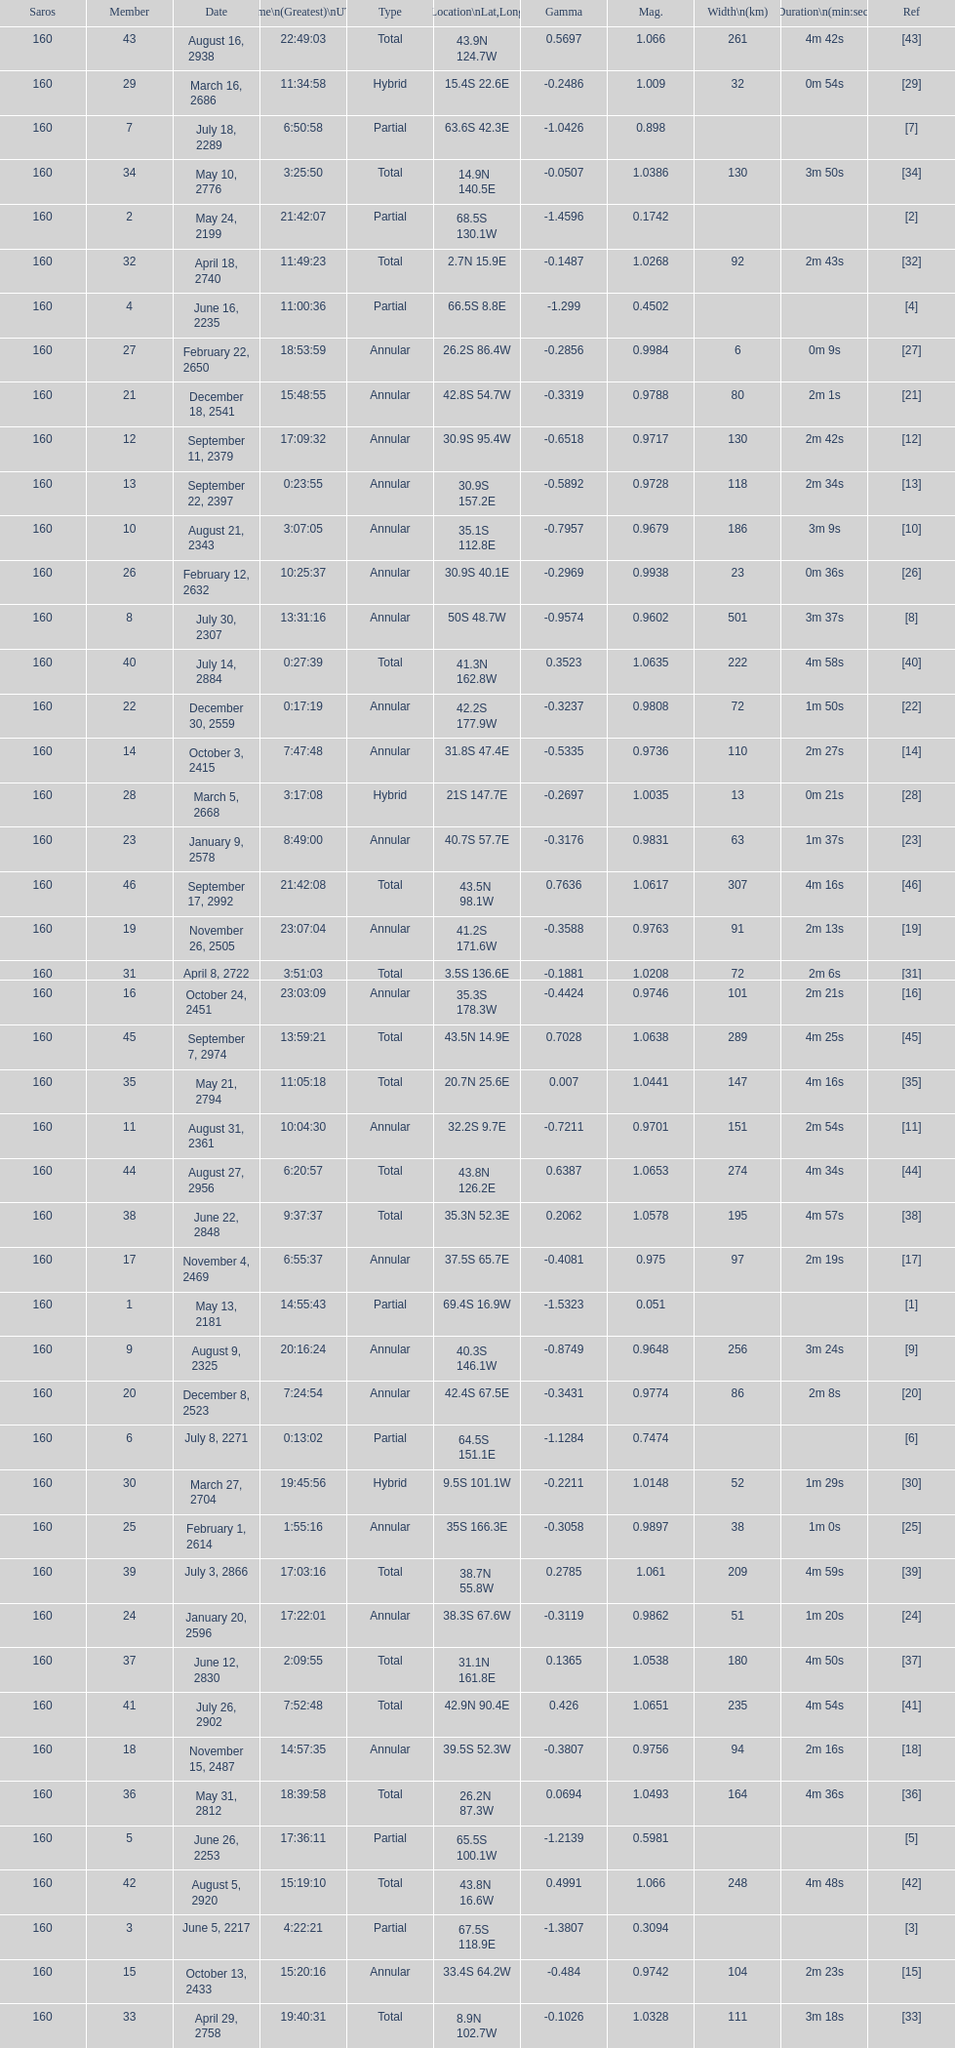Name a member number with a latitude above 60 s. 1. 